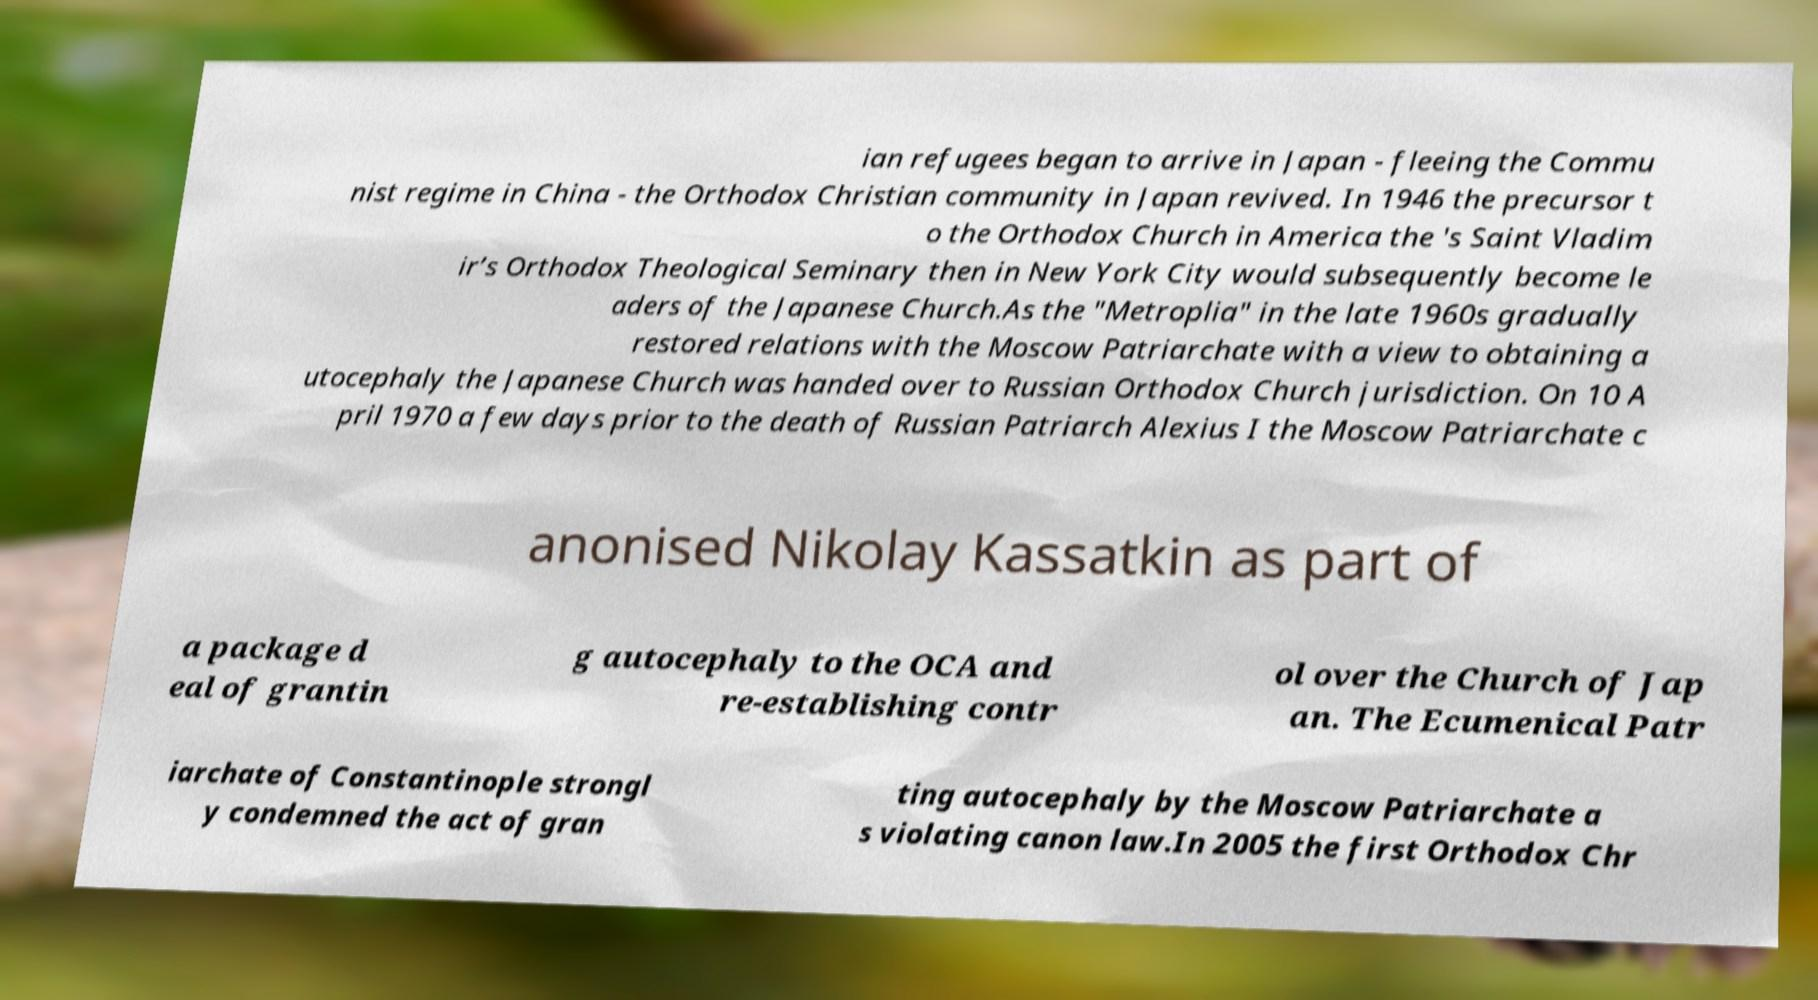Could you extract and type out the text from this image? ian refugees began to arrive in Japan - fleeing the Commu nist regime in China - the Orthodox Christian community in Japan revived. In 1946 the precursor t o the Orthodox Church in America the 's Saint Vladim ir’s Orthodox Theological Seminary then in New York City would subsequently become le aders of the Japanese Church.As the "Metroplia" in the late 1960s gradually restored relations with the Moscow Patriarchate with a view to obtaining a utocephaly the Japanese Church was handed over to Russian Orthodox Church jurisdiction. On 10 A pril 1970 a few days prior to the death of Russian Patriarch Alexius I the Moscow Patriarchate c anonised Nikolay Kassatkin as part of a package d eal of grantin g autocephaly to the OCA and re-establishing contr ol over the Church of Jap an. The Ecumenical Patr iarchate of Constantinople strongl y condemned the act of gran ting autocephaly by the Moscow Patriarchate a s violating canon law.In 2005 the first Orthodox Chr 